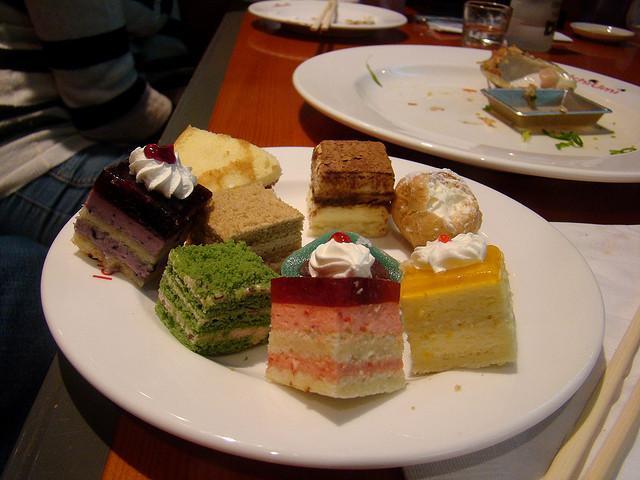How many cakes are present?
Give a very brief answer. 8. How many cakes are there?
Give a very brief answer. 9. How many giraffes are eating?
Give a very brief answer. 0. 